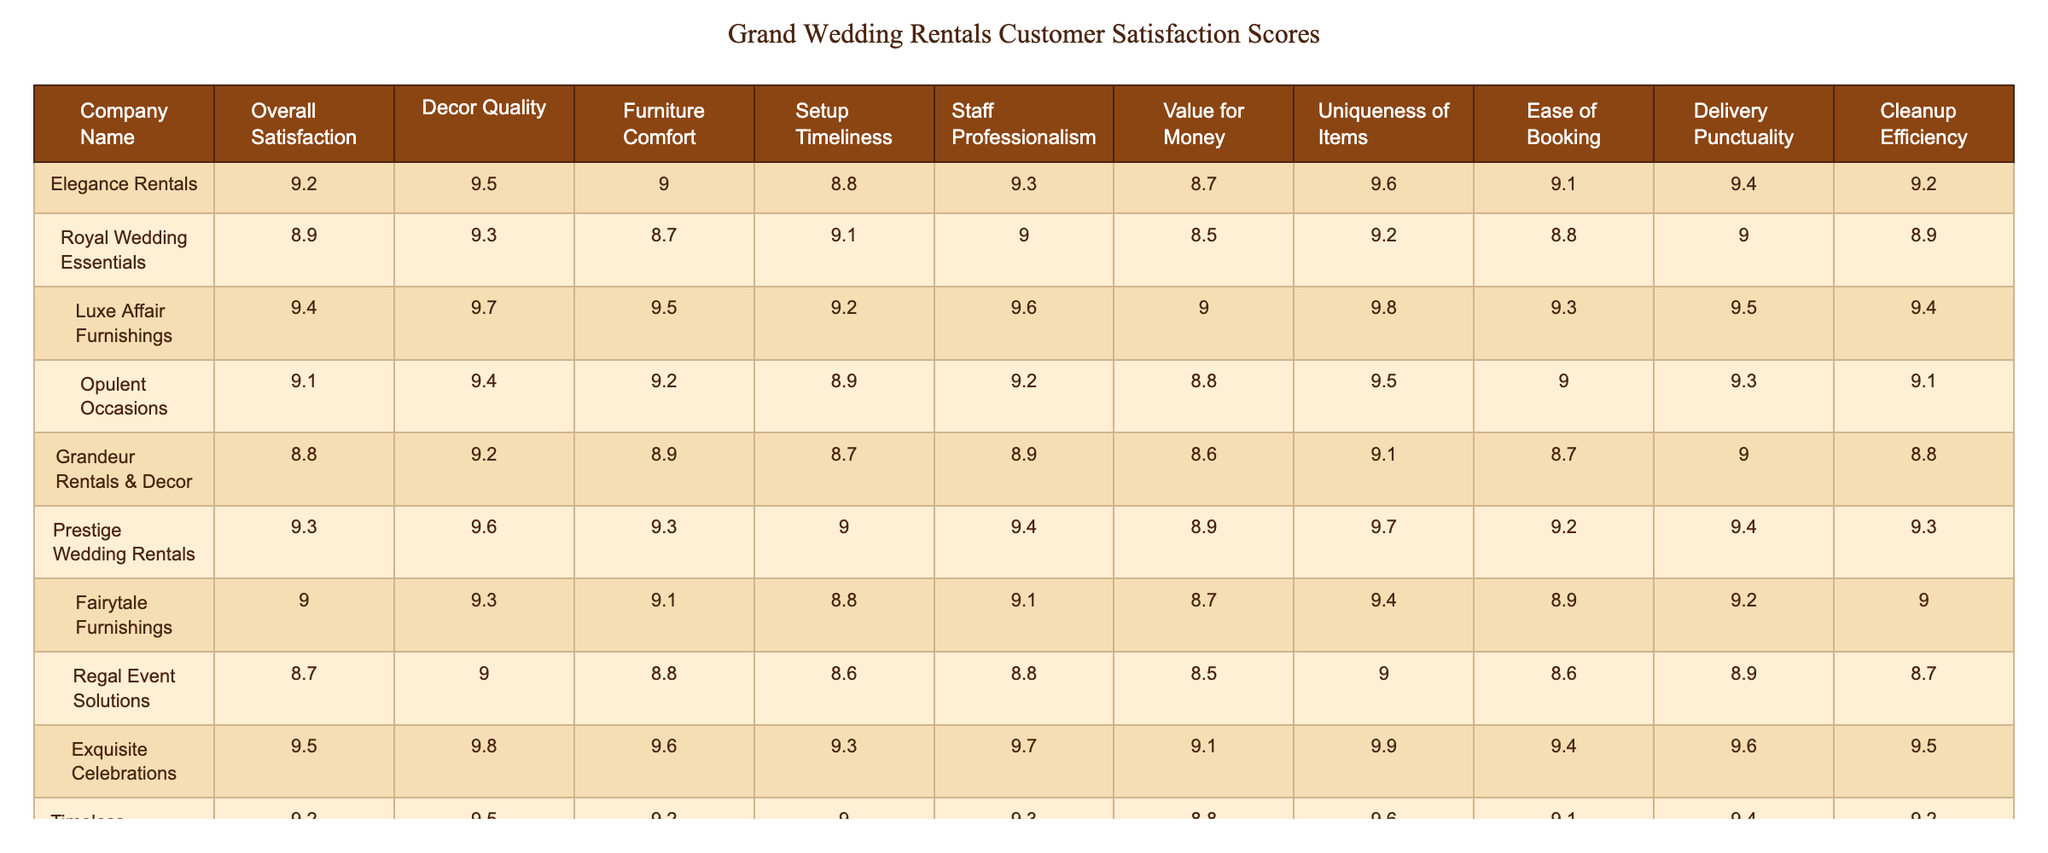What is the overall satisfaction score for Luxe Affair Furnishings? The overall satisfaction score is listed in the table under the column titled "Overall Satisfaction" for Luxe Affair Furnishings, which shows a score of 9.4.
Answer: 9.4 Which company has the highest score in decor quality? By examining the "Decor Quality" column, we see that Exquisite Celebrations has the highest score of 9.8 among all companies.
Answer: 9.8 What is the difference in value for money between Regal Event Solutions and Grandeur Rentals & Decor? To find the difference, we compare their scores in the "Value for Money" column: Regal Event Solutions has 8.5 and Grandeur Rentals & Decor has 8.6. The difference is 8.6 - 8.5 = 0.1.
Answer: 0.1 Which company has the highest uniqueness of items score, and what is that score? Looking at the "Uniqueness of Items" column, we see that Luxe Affair Furnishings has the highest score at 9.8.
Answer: Luxe Affair Furnishings; 9.8 What is the average delivery punctuality score for all companies? To find the average, sum up all the delivery punctuality scores (9.4 + 9.0 + 9.5 + 9.3 + 9.0 + 9.4 + 9.2 + 8.9 + 9.6 + 9.4 =  94.3) and divide by the number of companies (10), which gives us an average of 94.3 / 10 = 9.43.
Answer: 9.43 Is the overall satisfaction score for Fairytale Furnishings higher than 9? The overall satisfaction score for Fairytale Furnishings is 9.0, which is not higher than 9, so the statement is false.
Answer: False Which company has the lowest score in furniture comfort? By checking the "Furniture Comfort" column, we see that Regal Event Solutions has the lowest score of 8.8 in this category.
Answer: Regal Event Solutions; 8.8 What is the combined score for setup timeliness and staff professionalism for Prestige Wedding Rentals? To find the combined score, add the setup timeliness score of 9.0 and the staff professionalism score of 9.4 to get 9.0 + 9.4 = 18.4.
Answer: 18.4 How many companies received a score higher than 9 in ease of booking? Looking at the "Ease of Booking" column, we see that Exquisite Celebrations, Luxe Affair Furnishings, and Prestige Wedding Rentals all scored higher than 9, totaling 3 companies.
Answer: 3 Which aspect has the highest average score across all companies? To determine this, we calculate the average for each aspect: Decor Quality average = 9.4, Furniture Comfort average = 9.1, Setup Timeliness average = 9.0, Staff Professionalism average = 9.25, Value for Money average = 8.83, Uniqueness of Items average = 9.4, Ease of Booking average = 9.1, Delivery Punctuality average = 9.31, and Cleanup Efficiency average = 9.1. The highest average is for Decor Quality at 9.4.
Answer: Decor Quality; 9.4 